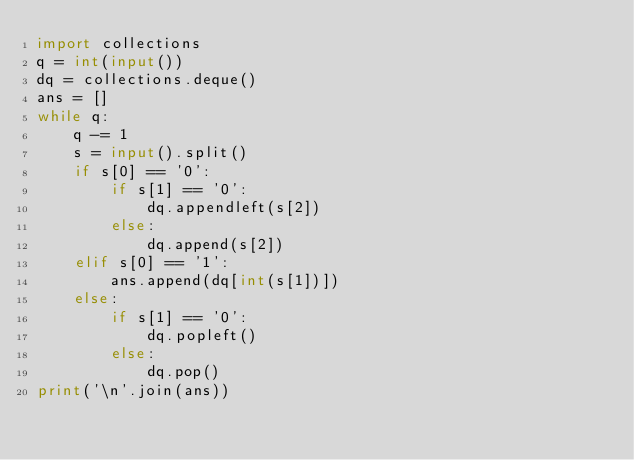Convert code to text. <code><loc_0><loc_0><loc_500><loc_500><_Python_>import collections
q = int(input())
dq = collections.deque()
ans = []
while q:
    q -= 1
    s = input().split()
    if s[0] == '0':
        if s[1] == '0':
            dq.appendleft(s[2])
        else:
            dq.append(s[2])
    elif s[0] == '1':
        ans.append(dq[int(s[1])])
    else:
        if s[1] == '0':
            dq.popleft()
        else:
            dq.pop()
print('\n'.join(ans))
</code> 